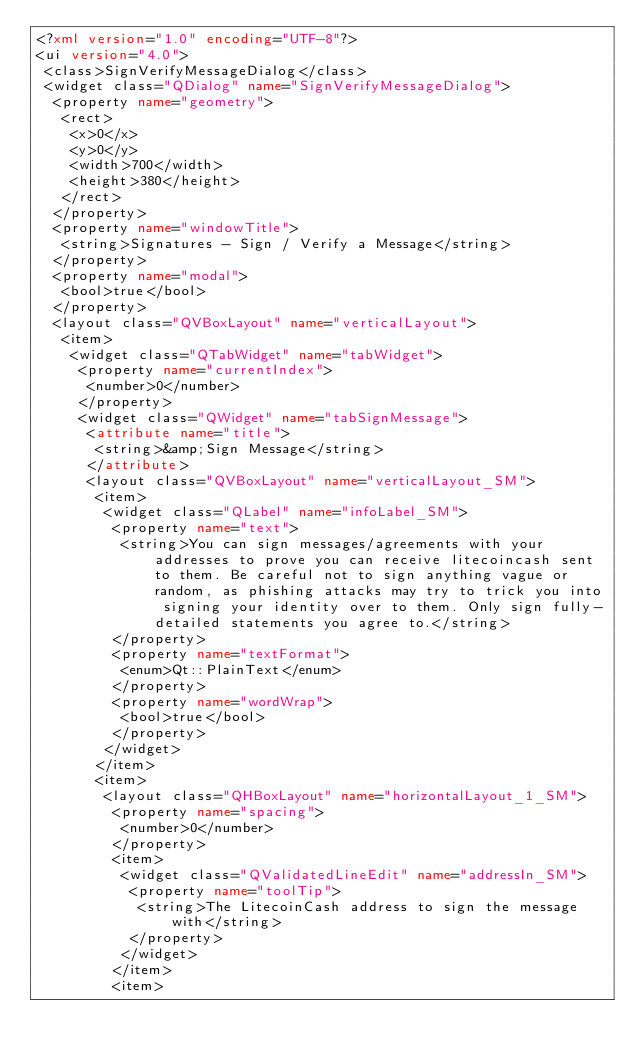Convert code to text. <code><loc_0><loc_0><loc_500><loc_500><_XML_><?xml version="1.0" encoding="UTF-8"?>
<ui version="4.0">
 <class>SignVerifyMessageDialog</class>
 <widget class="QDialog" name="SignVerifyMessageDialog">
  <property name="geometry">
   <rect>
    <x>0</x>
    <y>0</y>
    <width>700</width>
    <height>380</height>
   </rect>
  </property>
  <property name="windowTitle">
   <string>Signatures - Sign / Verify a Message</string>
  </property>
  <property name="modal">
   <bool>true</bool>
  </property>
  <layout class="QVBoxLayout" name="verticalLayout">
   <item>
    <widget class="QTabWidget" name="tabWidget">
     <property name="currentIndex">
      <number>0</number>
     </property>
     <widget class="QWidget" name="tabSignMessage">
      <attribute name="title">
       <string>&amp;Sign Message</string>
      </attribute>
      <layout class="QVBoxLayout" name="verticalLayout_SM">
       <item>
        <widget class="QLabel" name="infoLabel_SM">
         <property name="text">
          <string>You can sign messages/agreements with your addresses to prove you can receive litecoincash sent to them. Be careful not to sign anything vague or random, as phishing attacks may try to trick you into signing your identity over to them. Only sign fully-detailed statements you agree to.</string>
         </property>
         <property name="textFormat">
          <enum>Qt::PlainText</enum>
         </property>
         <property name="wordWrap">
          <bool>true</bool>
         </property>
        </widget>
       </item>
       <item>
        <layout class="QHBoxLayout" name="horizontalLayout_1_SM">
         <property name="spacing">
          <number>0</number>
         </property>
         <item>
          <widget class="QValidatedLineEdit" name="addressIn_SM">
           <property name="toolTip">
            <string>The LitecoinCash address to sign the message with</string>
           </property>
          </widget>
         </item>
         <item></code> 